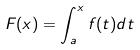Convert formula to latex. <formula><loc_0><loc_0><loc_500><loc_500>F ( x ) = \int _ { a } ^ { x } f ( t ) d t</formula> 